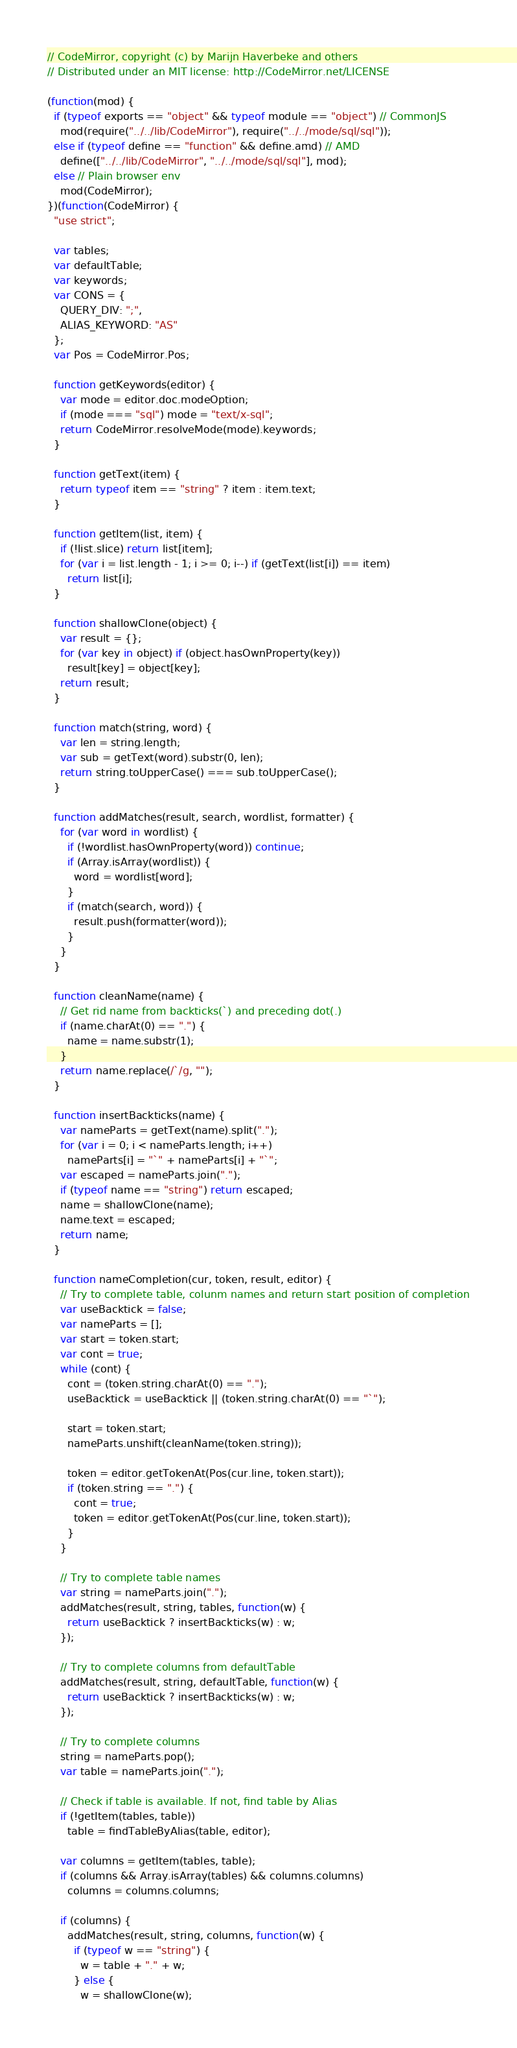Convert code to text. <code><loc_0><loc_0><loc_500><loc_500><_JavaScript_>// CodeMirror, copyright (c) by Marijn Haverbeke and others
// Distributed under an MIT license: http://CodeMirror.net/LICENSE

(function(mod) {
  if (typeof exports == "object" && typeof module == "object") // CommonJS
    mod(require("../../lib/CodeMirror"), require("../../mode/sql/sql"));
  else if (typeof define == "function" && define.amd) // AMD
    define(["../../lib/CodeMirror", "../../mode/sql/sql"], mod);
  else // Plain browser env
    mod(CodeMirror);
})(function(CodeMirror) {
  "use strict";

  var tables;
  var defaultTable;
  var keywords;
  var CONS = {
    QUERY_DIV: ";",
    ALIAS_KEYWORD: "AS"
  };
  var Pos = CodeMirror.Pos;

  function getKeywords(editor) {
    var mode = editor.doc.modeOption;
    if (mode === "sql") mode = "text/x-sql";
    return CodeMirror.resolveMode(mode).keywords;
  }

  function getText(item) {
    return typeof item == "string" ? item : item.text;
  }

  function getItem(list, item) {
    if (!list.slice) return list[item];
    for (var i = list.length - 1; i >= 0; i--) if (getText(list[i]) == item)
      return list[i];
  }

  function shallowClone(object) {
    var result = {};
    for (var key in object) if (object.hasOwnProperty(key))
      result[key] = object[key];
    return result;
  }

  function match(string, word) {
    var len = string.length;
    var sub = getText(word).substr(0, len);
    return string.toUpperCase() === sub.toUpperCase();
  }

  function addMatches(result, search, wordlist, formatter) {
    for (var word in wordlist) {
      if (!wordlist.hasOwnProperty(word)) continue;
      if (Array.isArray(wordlist)) {
        word = wordlist[word];
      }
      if (match(search, word)) {
        result.push(formatter(word));
      }
    }
  }

  function cleanName(name) {
    // Get rid name from backticks(`) and preceding dot(.)
    if (name.charAt(0) == ".") {
      name = name.substr(1);
    }
    return name.replace(/`/g, "");
  }

  function insertBackticks(name) {
    var nameParts = getText(name).split(".");
    for (var i = 0; i < nameParts.length; i++)
      nameParts[i] = "`" + nameParts[i] + "`";
    var escaped = nameParts.join(".");
    if (typeof name == "string") return escaped;
    name = shallowClone(name);
    name.text = escaped;
    return name;
  }

  function nameCompletion(cur, token, result, editor) {
    // Try to complete table, colunm names and return start position of completion
    var useBacktick = false;
    var nameParts = [];
    var start = token.start;
    var cont = true;
    while (cont) {
      cont = (token.string.charAt(0) == ".");
      useBacktick = useBacktick || (token.string.charAt(0) == "`");

      start = token.start;
      nameParts.unshift(cleanName(token.string));

      token = editor.getTokenAt(Pos(cur.line, token.start));
      if (token.string == ".") {
        cont = true;
        token = editor.getTokenAt(Pos(cur.line, token.start));
      }
    }

    // Try to complete table names
    var string = nameParts.join(".");
    addMatches(result, string, tables, function(w) {
      return useBacktick ? insertBackticks(w) : w;
    });

    // Try to complete columns from defaultTable
    addMatches(result, string, defaultTable, function(w) {
      return useBacktick ? insertBackticks(w) : w;
    });

    // Try to complete columns
    string = nameParts.pop();
    var table = nameParts.join(".");

    // Check if table is available. If not, find table by Alias
    if (!getItem(tables, table))
      table = findTableByAlias(table, editor);

    var columns = getItem(tables, table);
    if (columns && Array.isArray(tables) && columns.columns)
      columns = columns.columns;

    if (columns) {
      addMatches(result, string, columns, function(w) {
        if (typeof w == "string") {
          w = table + "." + w;
        } else {
          w = shallowClone(w);</code> 